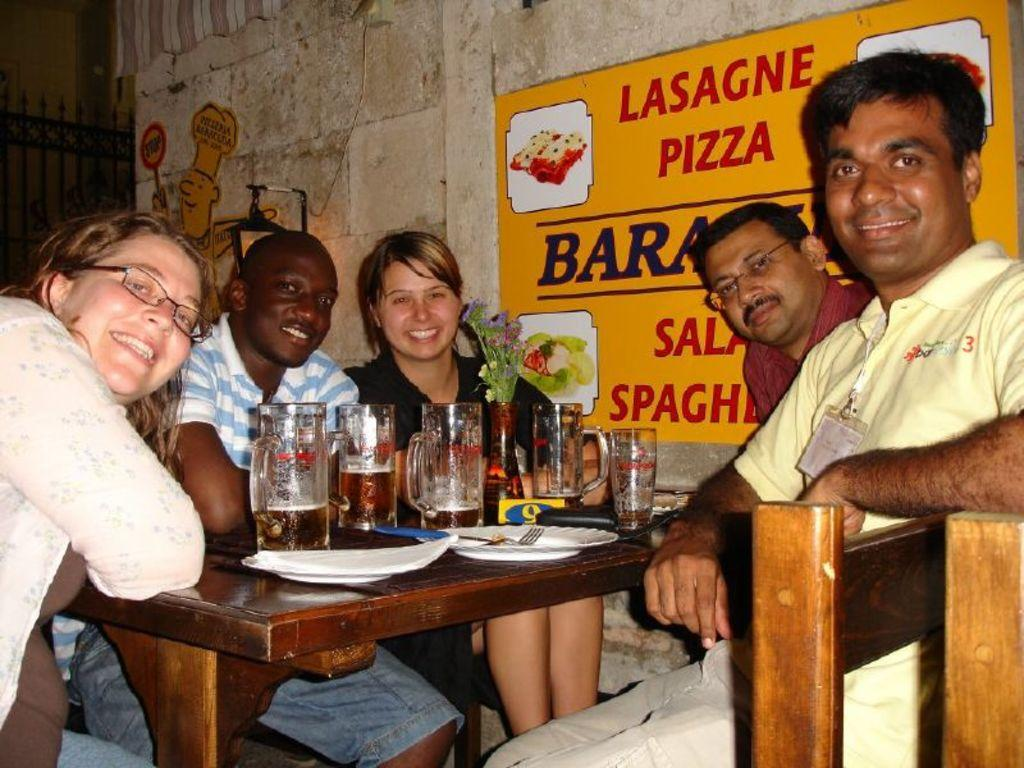What are the people in the image doing? The people are sitting in the image. What is the table they are sitting around made of? The table is made of wood. What items can be seen on the table? There are plates, forks, and glasses on the table. What is visible behind the people? There is a wall behind the people. What is written on the board in the image? The board has "lasagne pizza" written on it. What day of the week is it according to the calendar in the image? There is no calendar present in the image. Can you tell me how many toes the person on the left has? The image does not show the person's toes, so it cannot be determined. 